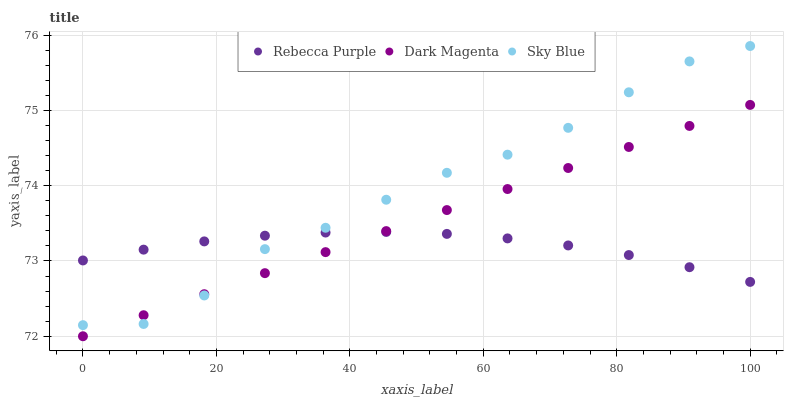Does Rebecca Purple have the minimum area under the curve?
Answer yes or no. Yes. Does Sky Blue have the maximum area under the curve?
Answer yes or no. Yes. Does Dark Magenta have the minimum area under the curve?
Answer yes or no. No. Does Dark Magenta have the maximum area under the curve?
Answer yes or no. No. Is Dark Magenta the smoothest?
Answer yes or no. Yes. Is Sky Blue the roughest?
Answer yes or no. Yes. Is Rebecca Purple the smoothest?
Answer yes or no. No. Is Rebecca Purple the roughest?
Answer yes or no. No. Does Dark Magenta have the lowest value?
Answer yes or no. Yes. Does Rebecca Purple have the lowest value?
Answer yes or no. No. Does Sky Blue have the highest value?
Answer yes or no. Yes. Does Dark Magenta have the highest value?
Answer yes or no. No. Does Sky Blue intersect Dark Magenta?
Answer yes or no. Yes. Is Sky Blue less than Dark Magenta?
Answer yes or no. No. Is Sky Blue greater than Dark Magenta?
Answer yes or no. No. 